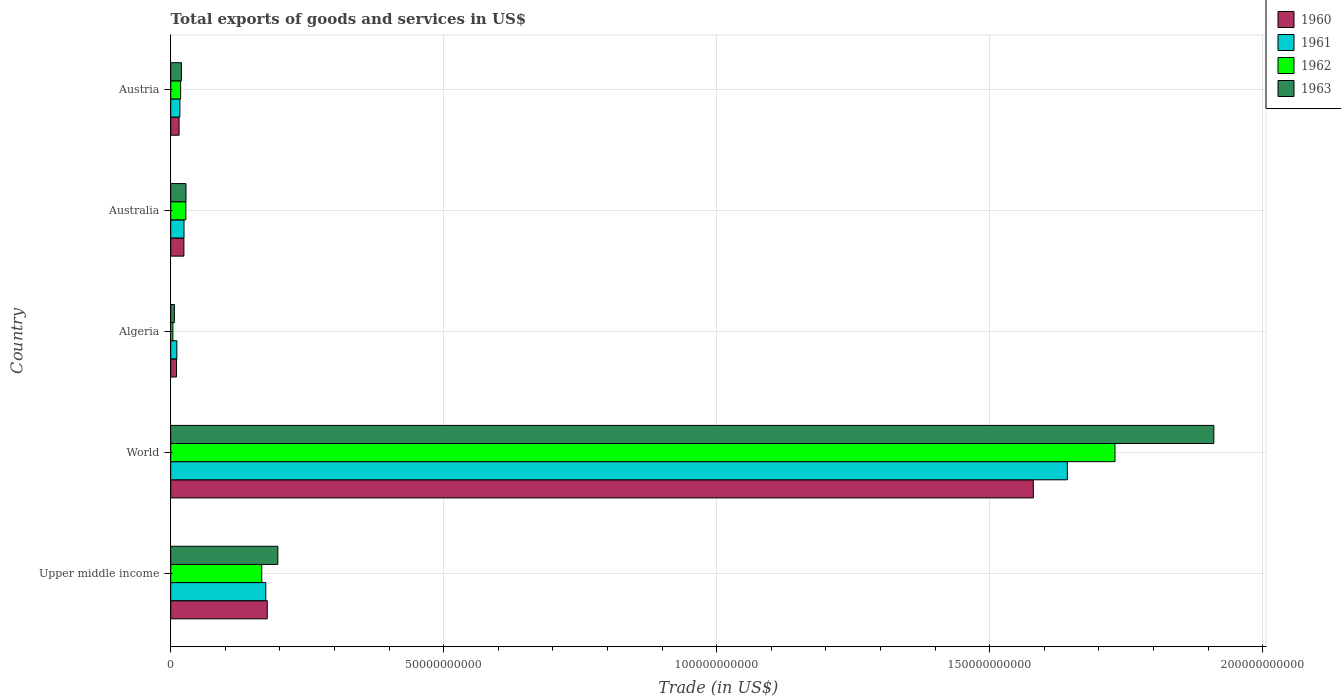Are the number of bars per tick equal to the number of legend labels?
Provide a succinct answer. Yes. Are the number of bars on each tick of the Y-axis equal?
Make the answer very short. Yes. How many bars are there on the 4th tick from the bottom?
Your response must be concise. 4. What is the label of the 3rd group of bars from the top?
Give a very brief answer. Algeria. What is the total exports of goods and services in 1963 in Austria?
Your response must be concise. 1.96e+09. Across all countries, what is the maximum total exports of goods and services in 1963?
Make the answer very short. 1.91e+11. Across all countries, what is the minimum total exports of goods and services in 1962?
Your response must be concise. 3.96e+08. In which country was the total exports of goods and services in 1960 minimum?
Ensure brevity in your answer.  Algeria. What is the total total exports of goods and services in 1960 in the graph?
Your answer should be very brief. 1.81e+11. What is the difference between the total exports of goods and services in 1963 in Algeria and that in Austria?
Your answer should be very brief. -1.29e+09. What is the difference between the total exports of goods and services in 1962 in World and the total exports of goods and services in 1961 in Algeria?
Provide a short and direct response. 1.72e+11. What is the average total exports of goods and services in 1963 per country?
Ensure brevity in your answer.  4.32e+1. What is the difference between the total exports of goods and services in 1963 and total exports of goods and services in 1961 in World?
Make the answer very short. 2.68e+1. What is the ratio of the total exports of goods and services in 1962 in Algeria to that in Upper middle income?
Make the answer very short. 0.02. What is the difference between the highest and the second highest total exports of goods and services in 1963?
Make the answer very short. 1.71e+11. What is the difference between the highest and the lowest total exports of goods and services in 1961?
Your response must be concise. 1.63e+11. In how many countries, is the total exports of goods and services in 1960 greater than the average total exports of goods and services in 1960 taken over all countries?
Offer a very short reply. 1. How many bars are there?
Your answer should be very brief. 20. What is the difference between two consecutive major ticks on the X-axis?
Give a very brief answer. 5.00e+1. Does the graph contain grids?
Ensure brevity in your answer.  Yes. How many legend labels are there?
Offer a very short reply. 4. What is the title of the graph?
Give a very brief answer. Total exports of goods and services in US$. What is the label or title of the X-axis?
Your response must be concise. Trade (in US$). What is the label or title of the Y-axis?
Your response must be concise. Country. What is the Trade (in US$) of 1960 in Upper middle income?
Offer a very short reply. 1.77e+1. What is the Trade (in US$) of 1961 in Upper middle income?
Ensure brevity in your answer.  1.74e+1. What is the Trade (in US$) in 1962 in Upper middle income?
Provide a succinct answer. 1.67e+1. What is the Trade (in US$) in 1963 in Upper middle income?
Make the answer very short. 1.96e+1. What is the Trade (in US$) of 1960 in World?
Keep it short and to the point. 1.58e+11. What is the Trade (in US$) in 1961 in World?
Your answer should be very brief. 1.64e+11. What is the Trade (in US$) of 1962 in World?
Provide a succinct answer. 1.73e+11. What is the Trade (in US$) in 1963 in World?
Offer a very short reply. 1.91e+11. What is the Trade (in US$) of 1960 in Algeria?
Provide a short and direct response. 1.06e+09. What is the Trade (in US$) of 1961 in Algeria?
Your answer should be compact. 1.13e+09. What is the Trade (in US$) of 1962 in Algeria?
Make the answer very short. 3.96e+08. What is the Trade (in US$) of 1963 in Algeria?
Make the answer very short. 6.67e+08. What is the Trade (in US$) in 1960 in Australia?
Provide a succinct answer. 2.41e+09. What is the Trade (in US$) of 1961 in Australia?
Offer a terse response. 2.44e+09. What is the Trade (in US$) of 1962 in Australia?
Keep it short and to the point. 2.77e+09. What is the Trade (in US$) in 1963 in Australia?
Give a very brief answer. 2.80e+09. What is the Trade (in US$) in 1960 in Austria?
Provide a short and direct response. 1.53e+09. What is the Trade (in US$) of 1961 in Austria?
Offer a very short reply. 1.68e+09. What is the Trade (in US$) in 1962 in Austria?
Give a very brief answer. 1.82e+09. What is the Trade (in US$) of 1963 in Austria?
Provide a succinct answer. 1.96e+09. Across all countries, what is the maximum Trade (in US$) of 1960?
Keep it short and to the point. 1.58e+11. Across all countries, what is the maximum Trade (in US$) in 1961?
Ensure brevity in your answer.  1.64e+11. Across all countries, what is the maximum Trade (in US$) in 1962?
Make the answer very short. 1.73e+11. Across all countries, what is the maximum Trade (in US$) in 1963?
Ensure brevity in your answer.  1.91e+11. Across all countries, what is the minimum Trade (in US$) in 1960?
Keep it short and to the point. 1.06e+09. Across all countries, what is the minimum Trade (in US$) in 1961?
Make the answer very short. 1.13e+09. Across all countries, what is the minimum Trade (in US$) of 1962?
Keep it short and to the point. 3.96e+08. Across all countries, what is the minimum Trade (in US$) in 1963?
Give a very brief answer. 6.67e+08. What is the total Trade (in US$) in 1960 in the graph?
Provide a succinct answer. 1.81e+11. What is the total Trade (in US$) in 1961 in the graph?
Give a very brief answer. 1.87e+11. What is the total Trade (in US$) of 1962 in the graph?
Provide a short and direct response. 1.95e+11. What is the total Trade (in US$) in 1963 in the graph?
Keep it short and to the point. 2.16e+11. What is the difference between the Trade (in US$) in 1960 in Upper middle income and that in World?
Give a very brief answer. -1.40e+11. What is the difference between the Trade (in US$) in 1961 in Upper middle income and that in World?
Provide a succinct answer. -1.47e+11. What is the difference between the Trade (in US$) of 1962 in Upper middle income and that in World?
Offer a very short reply. -1.56e+11. What is the difference between the Trade (in US$) of 1963 in Upper middle income and that in World?
Ensure brevity in your answer.  -1.71e+11. What is the difference between the Trade (in US$) in 1960 in Upper middle income and that in Algeria?
Give a very brief answer. 1.66e+1. What is the difference between the Trade (in US$) of 1961 in Upper middle income and that in Algeria?
Provide a succinct answer. 1.63e+1. What is the difference between the Trade (in US$) of 1962 in Upper middle income and that in Algeria?
Provide a short and direct response. 1.63e+1. What is the difference between the Trade (in US$) of 1963 in Upper middle income and that in Algeria?
Provide a succinct answer. 1.90e+1. What is the difference between the Trade (in US$) of 1960 in Upper middle income and that in Australia?
Offer a very short reply. 1.53e+1. What is the difference between the Trade (in US$) in 1961 in Upper middle income and that in Australia?
Offer a very short reply. 1.50e+1. What is the difference between the Trade (in US$) of 1962 in Upper middle income and that in Australia?
Make the answer very short. 1.39e+1. What is the difference between the Trade (in US$) in 1963 in Upper middle income and that in Australia?
Keep it short and to the point. 1.68e+1. What is the difference between the Trade (in US$) in 1960 in Upper middle income and that in Austria?
Ensure brevity in your answer.  1.62e+1. What is the difference between the Trade (in US$) of 1961 in Upper middle income and that in Austria?
Provide a short and direct response. 1.57e+1. What is the difference between the Trade (in US$) of 1962 in Upper middle income and that in Austria?
Provide a succinct answer. 1.49e+1. What is the difference between the Trade (in US$) in 1963 in Upper middle income and that in Austria?
Make the answer very short. 1.77e+1. What is the difference between the Trade (in US$) in 1960 in World and that in Algeria?
Provide a short and direct response. 1.57e+11. What is the difference between the Trade (in US$) of 1961 in World and that in Algeria?
Provide a succinct answer. 1.63e+11. What is the difference between the Trade (in US$) in 1962 in World and that in Algeria?
Give a very brief answer. 1.73e+11. What is the difference between the Trade (in US$) in 1963 in World and that in Algeria?
Your answer should be compact. 1.90e+11. What is the difference between the Trade (in US$) of 1960 in World and that in Australia?
Provide a short and direct response. 1.56e+11. What is the difference between the Trade (in US$) in 1961 in World and that in Australia?
Provide a succinct answer. 1.62e+11. What is the difference between the Trade (in US$) in 1962 in World and that in Australia?
Your answer should be compact. 1.70e+11. What is the difference between the Trade (in US$) in 1963 in World and that in Australia?
Offer a very short reply. 1.88e+11. What is the difference between the Trade (in US$) in 1960 in World and that in Austria?
Offer a very short reply. 1.56e+11. What is the difference between the Trade (in US$) of 1961 in World and that in Austria?
Ensure brevity in your answer.  1.63e+11. What is the difference between the Trade (in US$) in 1962 in World and that in Austria?
Ensure brevity in your answer.  1.71e+11. What is the difference between the Trade (in US$) of 1963 in World and that in Austria?
Your answer should be very brief. 1.89e+11. What is the difference between the Trade (in US$) in 1960 in Algeria and that in Australia?
Make the answer very short. -1.35e+09. What is the difference between the Trade (in US$) of 1961 in Algeria and that in Australia?
Give a very brief answer. -1.31e+09. What is the difference between the Trade (in US$) of 1962 in Algeria and that in Australia?
Offer a terse response. -2.38e+09. What is the difference between the Trade (in US$) in 1963 in Algeria and that in Australia?
Keep it short and to the point. -2.13e+09. What is the difference between the Trade (in US$) of 1960 in Algeria and that in Austria?
Ensure brevity in your answer.  -4.69e+08. What is the difference between the Trade (in US$) of 1961 in Algeria and that in Austria?
Offer a terse response. -5.56e+08. What is the difference between the Trade (in US$) of 1962 in Algeria and that in Austria?
Make the answer very short. -1.42e+09. What is the difference between the Trade (in US$) of 1963 in Algeria and that in Austria?
Give a very brief answer. -1.29e+09. What is the difference between the Trade (in US$) in 1960 in Australia and that in Austria?
Provide a short and direct response. 8.81e+08. What is the difference between the Trade (in US$) in 1961 in Australia and that in Austria?
Your answer should be compact. 7.55e+08. What is the difference between the Trade (in US$) of 1962 in Australia and that in Austria?
Your answer should be compact. 9.57e+08. What is the difference between the Trade (in US$) in 1963 in Australia and that in Austria?
Give a very brief answer. 8.35e+08. What is the difference between the Trade (in US$) of 1960 in Upper middle income and the Trade (in US$) of 1961 in World?
Give a very brief answer. -1.47e+11. What is the difference between the Trade (in US$) in 1960 in Upper middle income and the Trade (in US$) in 1962 in World?
Keep it short and to the point. -1.55e+11. What is the difference between the Trade (in US$) in 1960 in Upper middle income and the Trade (in US$) in 1963 in World?
Offer a terse response. -1.73e+11. What is the difference between the Trade (in US$) of 1961 in Upper middle income and the Trade (in US$) of 1962 in World?
Make the answer very short. -1.56e+11. What is the difference between the Trade (in US$) in 1961 in Upper middle income and the Trade (in US$) in 1963 in World?
Your answer should be compact. -1.74e+11. What is the difference between the Trade (in US$) in 1962 in Upper middle income and the Trade (in US$) in 1963 in World?
Your answer should be very brief. -1.74e+11. What is the difference between the Trade (in US$) in 1960 in Upper middle income and the Trade (in US$) in 1961 in Algeria?
Your answer should be compact. 1.66e+1. What is the difference between the Trade (in US$) of 1960 in Upper middle income and the Trade (in US$) of 1962 in Algeria?
Ensure brevity in your answer.  1.73e+1. What is the difference between the Trade (in US$) of 1960 in Upper middle income and the Trade (in US$) of 1963 in Algeria?
Give a very brief answer. 1.70e+1. What is the difference between the Trade (in US$) in 1961 in Upper middle income and the Trade (in US$) in 1962 in Algeria?
Offer a terse response. 1.70e+1. What is the difference between the Trade (in US$) of 1961 in Upper middle income and the Trade (in US$) of 1963 in Algeria?
Provide a short and direct response. 1.67e+1. What is the difference between the Trade (in US$) of 1962 in Upper middle income and the Trade (in US$) of 1963 in Algeria?
Offer a very short reply. 1.60e+1. What is the difference between the Trade (in US$) of 1960 in Upper middle income and the Trade (in US$) of 1961 in Australia?
Keep it short and to the point. 1.52e+1. What is the difference between the Trade (in US$) of 1960 in Upper middle income and the Trade (in US$) of 1962 in Australia?
Offer a terse response. 1.49e+1. What is the difference between the Trade (in US$) of 1960 in Upper middle income and the Trade (in US$) of 1963 in Australia?
Offer a terse response. 1.49e+1. What is the difference between the Trade (in US$) of 1961 in Upper middle income and the Trade (in US$) of 1962 in Australia?
Make the answer very short. 1.46e+1. What is the difference between the Trade (in US$) in 1961 in Upper middle income and the Trade (in US$) in 1963 in Australia?
Make the answer very short. 1.46e+1. What is the difference between the Trade (in US$) of 1962 in Upper middle income and the Trade (in US$) of 1963 in Australia?
Your answer should be compact. 1.39e+1. What is the difference between the Trade (in US$) of 1960 in Upper middle income and the Trade (in US$) of 1961 in Austria?
Ensure brevity in your answer.  1.60e+1. What is the difference between the Trade (in US$) of 1960 in Upper middle income and the Trade (in US$) of 1962 in Austria?
Give a very brief answer. 1.59e+1. What is the difference between the Trade (in US$) in 1960 in Upper middle income and the Trade (in US$) in 1963 in Austria?
Your answer should be compact. 1.57e+1. What is the difference between the Trade (in US$) of 1961 in Upper middle income and the Trade (in US$) of 1962 in Austria?
Offer a very short reply. 1.56e+1. What is the difference between the Trade (in US$) in 1961 in Upper middle income and the Trade (in US$) in 1963 in Austria?
Provide a short and direct response. 1.55e+1. What is the difference between the Trade (in US$) of 1962 in Upper middle income and the Trade (in US$) of 1963 in Austria?
Keep it short and to the point. 1.47e+1. What is the difference between the Trade (in US$) of 1960 in World and the Trade (in US$) of 1961 in Algeria?
Keep it short and to the point. 1.57e+11. What is the difference between the Trade (in US$) of 1960 in World and the Trade (in US$) of 1962 in Algeria?
Ensure brevity in your answer.  1.58e+11. What is the difference between the Trade (in US$) in 1960 in World and the Trade (in US$) in 1963 in Algeria?
Offer a terse response. 1.57e+11. What is the difference between the Trade (in US$) of 1961 in World and the Trade (in US$) of 1962 in Algeria?
Your answer should be compact. 1.64e+11. What is the difference between the Trade (in US$) in 1961 in World and the Trade (in US$) in 1963 in Algeria?
Offer a very short reply. 1.64e+11. What is the difference between the Trade (in US$) of 1962 in World and the Trade (in US$) of 1963 in Algeria?
Give a very brief answer. 1.72e+11. What is the difference between the Trade (in US$) in 1960 in World and the Trade (in US$) in 1961 in Australia?
Ensure brevity in your answer.  1.56e+11. What is the difference between the Trade (in US$) in 1960 in World and the Trade (in US$) in 1962 in Australia?
Your response must be concise. 1.55e+11. What is the difference between the Trade (in US$) of 1960 in World and the Trade (in US$) of 1963 in Australia?
Your answer should be compact. 1.55e+11. What is the difference between the Trade (in US$) in 1961 in World and the Trade (in US$) in 1962 in Australia?
Make the answer very short. 1.61e+11. What is the difference between the Trade (in US$) of 1961 in World and the Trade (in US$) of 1963 in Australia?
Make the answer very short. 1.61e+11. What is the difference between the Trade (in US$) of 1962 in World and the Trade (in US$) of 1963 in Australia?
Give a very brief answer. 1.70e+11. What is the difference between the Trade (in US$) in 1960 in World and the Trade (in US$) in 1961 in Austria?
Offer a very short reply. 1.56e+11. What is the difference between the Trade (in US$) in 1960 in World and the Trade (in US$) in 1962 in Austria?
Ensure brevity in your answer.  1.56e+11. What is the difference between the Trade (in US$) in 1960 in World and the Trade (in US$) in 1963 in Austria?
Your answer should be compact. 1.56e+11. What is the difference between the Trade (in US$) in 1961 in World and the Trade (in US$) in 1962 in Austria?
Keep it short and to the point. 1.62e+11. What is the difference between the Trade (in US$) in 1961 in World and the Trade (in US$) in 1963 in Austria?
Provide a short and direct response. 1.62e+11. What is the difference between the Trade (in US$) of 1962 in World and the Trade (in US$) of 1963 in Austria?
Your answer should be very brief. 1.71e+11. What is the difference between the Trade (in US$) in 1960 in Algeria and the Trade (in US$) in 1961 in Australia?
Ensure brevity in your answer.  -1.37e+09. What is the difference between the Trade (in US$) in 1960 in Algeria and the Trade (in US$) in 1962 in Australia?
Keep it short and to the point. -1.71e+09. What is the difference between the Trade (in US$) of 1960 in Algeria and the Trade (in US$) of 1963 in Australia?
Provide a succinct answer. -1.73e+09. What is the difference between the Trade (in US$) of 1961 in Algeria and the Trade (in US$) of 1962 in Australia?
Provide a succinct answer. -1.65e+09. What is the difference between the Trade (in US$) of 1961 in Algeria and the Trade (in US$) of 1963 in Australia?
Provide a succinct answer. -1.67e+09. What is the difference between the Trade (in US$) of 1962 in Algeria and the Trade (in US$) of 1963 in Australia?
Provide a succinct answer. -2.40e+09. What is the difference between the Trade (in US$) of 1960 in Algeria and the Trade (in US$) of 1961 in Austria?
Your answer should be compact. -6.19e+08. What is the difference between the Trade (in US$) in 1960 in Algeria and the Trade (in US$) in 1962 in Austria?
Provide a succinct answer. -7.53e+08. What is the difference between the Trade (in US$) of 1960 in Algeria and the Trade (in US$) of 1963 in Austria?
Make the answer very short. -8.98e+08. What is the difference between the Trade (in US$) of 1961 in Algeria and the Trade (in US$) of 1962 in Austria?
Provide a succinct answer. -6.90e+08. What is the difference between the Trade (in US$) of 1961 in Algeria and the Trade (in US$) of 1963 in Austria?
Keep it short and to the point. -8.36e+08. What is the difference between the Trade (in US$) in 1962 in Algeria and the Trade (in US$) in 1963 in Austria?
Your answer should be compact. -1.57e+09. What is the difference between the Trade (in US$) in 1960 in Australia and the Trade (in US$) in 1961 in Austria?
Make the answer very short. 7.31e+08. What is the difference between the Trade (in US$) in 1960 in Australia and the Trade (in US$) in 1962 in Austria?
Provide a succinct answer. 5.97e+08. What is the difference between the Trade (in US$) in 1960 in Australia and the Trade (in US$) in 1963 in Austria?
Ensure brevity in your answer.  4.52e+08. What is the difference between the Trade (in US$) of 1961 in Australia and the Trade (in US$) of 1962 in Austria?
Offer a terse response. 6.21e+08. What is the difference between the Trade (in US$) of 1961 in Australia and the Trade (in US$) of 1963 in Austria?
Offer a very short reply. 4.75e+08. What is the difference between the Trade (in US$) in 1962 in Australia and the Trade (in US$) in 1963 in Austria?
Your response must be concise. 8.11e+08. What is the average Trade (in US$) in 1960 per country?
Ensure brevity in your answer.  3.61e+1. What is the average Trade (in US$) of 1961 per country?
Make the answer very short. 3.74e+1. What is the average Trade (in US$) of 1962 per country?
Your answer should be very brief. 3.89e+1. What is the average Trade (in US$) in 1963 per country?
Your response must be concise. 4.32e+1. What is the difference between the Trade (in US$) in 1960 and Trade (in US$) in 1961 in Upper middle income?
Ensure brevity in your answer.  2.71e+08. What is the difference between the Trade (in US$) of 1960 and Trade (in US$) of 1962 in Upper middle income?
Offer a terse response. 1.01e+09. What is the difference between the Trade (in US$) in 1960 and Trade (in US$) in 1963 in Upper middle income?
Make the answer very short. -1.93e+09. What is the difference between the Trade (in US$) of 1961 and Trade (in US$) of 1962 in Upper middle income?
Offer a terse response. 7.39e+08. What is the difference between the Trade (in US$) in 1961 and Trade (in US$) in 1963 in Upper middle income?
Provide a short and direct response. -2.21e+09. What is the difference between the Trade (in US$) of 1962 and Trade (in US$) of 1963 in Upper middle income?
Provide a succinct answer. -2.95e+09. What is the difference between the Trade (in US$) in 1960 and Trade (in US$) in 1961 in World?
Your answer should be compact. -6.23e+09. What is the difference between the Trade (in US$) of 1960 and Trade (in US$) of 1962 in World?
Provide a succinct answer. -1.50e+1. What is the difference between the Trade (in US$) in 1960 and Trade (in US$) in 1963 in World?
Give a very brief answer. -3.31e+1. What is the difference between the Trade (in US$) in 1961 and Trade (in US$) in 1962 in World?
Offer a terse response. -8.73e+09. What is the difference between the Trade (in US$) of 1961 and Trade (in US$) of 1963 in World?
Your answer should be very brief. -2.68e+1. What is the difference between the Trade (in US$) of 1962 and Trade (in US$) of 1963 in World?
Keep it short and to the point. -1.81e+1. What is the difference between the Trade (in US$) of 1960 and Trade (in US$) of 1961 in Algeria?
Give a very brief answer. -6.26e+07. What is the difference between the Trade (in US$) in 1960 and Trade (in US$) in 1962 in Algeria?
Your response must be concise. 6.67e+08. What is the difference between the Trade (in US$) in 1960 and Trade (in US$) in 1963 in Algeria?
Offer a terse response. 3.96e+08. What is the difference between the Trade (in US$) in 1961 and Trade (in US$) in 1962 in Algeria?
Keep it short and to the point. 7.30e+08. What is the difference between the Trade (in US$) in 1961 and Trade (in US$) in 1963 in Algeria?
Provide a short and direct response. 4.59e+08. What is the difference between the Trade (in US$) in 1962 and Trade (in US$) in 1963 in Algeria?
Offer a very short reply. -2.71e+08. What is the difference between the Trade (in US$) of 1960 and Trade (in US$) of 1961 in Australia?
Ensure brevity in your answer.  -2.35e+07. What is the difference between the Trade (in US$) in 1960 and Trade (in US$) in 1962 in Australia?
Your answer should be very brief. -3.60e+08. What is the difference between the Trade (in US$) in 1960 and Trade (in US$) in 1963 in Australia?
Make the answer very short. -3.83e+08. What is the difference between the Trade (in US$) of 1961 and Trade (in US$) of 1962 in Australia?
Your answer should be compact. -3.36e+08. What is the difference between the Trade (in US$) of 1961 and Trade (in US$) of 1963 in Australia?
Keep it short and to the point. -3.60e+08. What is the difference between the Trade (in US$) in 1962 and Trade (in US$) in 1963 in Australia?
Your answer should be compact. -2.35e+07. What is the difference between the Trade (in US$) in 1960 and Trade (in US$) in 1961 in Austria?
Offer a terse response. -1.49e+08. What is the difference between the Trade (in US$) in 1960 and Trade (in US$) in 1962 in Austria?
Provide a short and direct response. -2.84e+08. What is the difference between the Trade (in US$) in 1960 and Trade (in US$) in 1963 in Austria?
Keep it short and to the point. -4.29e+08. What is the difference between the Trade (in US$) of 1961 and Trade (in US$) of 1962 in Austria?
Offer a terse response. -1.34e+08. What is the difference between the Trade (in US$) of 1961 and Trade (in US$) of 1963 in Austria?
Make the answer very short. -2.80e+08. What is the difference between the Trade (in US$) in 1962 and Trade (in US$) in 1963 in Austria?
Offer a terse response. -1.46e+08. What is the ratio of the Trade (in US$) of 1960 in Upper middle income to that in World?
Your answer should be very brief. 0.11. What is the ratio of the Trade (in US$) of 1961 in Upper middle income to that in World?
Provide a succinct answer. 0.11. What is the ratio of the Trade (in US$) in 1962 in Upper middle income to that in World?
Your answer should be compact. 0.1. What is the ratio of the Trade (in US$) of 1963 in Upper middle income to that in World?
Keep it short and to the point. 0.1. What is the ratio of the Trade (in US$) of 1960 in Upper middle income to that in Algeria?
Offer a very short reply. 16.63. What is the ratio of the Trade (in US$) in 1961 in Upper middle income to that in Algeria?
Provide a succinct answer. 15.47. What is the ratio of the Trade (in US$) in 1962 in Upper middle income to that in Algeria?
Your answer should be very brief. 42.09. What is the ratio of the Trade (in US$) in 1963 in Upper middle income to that in Algeria?
Your response must be concise. 29.41. What is the ratio of the Trade (in US$) of 1960 in Upper middle income to that in Australia?
Your answer should be compact. 7.33. What is the ratio of the Trade (in US$) in 1961 in Upper middle income to that in Australia?
Offer a very short reply. 7.15. What is the ratio of the Trade (in US$) of 1962 in Upper middle income to that in Australia?
Keep it short and to the point. 6.01. What is the ratio of the Trade (in US$) in 1963 in Upper middle income to that in Australia?
Provide a short and direct response. 7.02. What is the ratio of the Trade (in US$) in 1960 in Upper middle income to that in Austria?
Ensure brevity in your answer.  11.54. What is the ratio of the Trade (in US$) in 1961 in Upper middle income to that in Austria?
Ensure brevity in your answer.  10.35. What is the ratio of the Trade (in US$) in 1962 in Upper middle income to that in Austria?
Your answer should be compact. 9.18. What is the ratio of the Trade (in US$) of 1963 in Upper middle income to that in Austria?
Offer a terse response. 10. What is the ratio of the Trade (in US$) of 1960 in World to that in Algeria?
Make the answer very short. 148.58. What is the ratio of the Trade (in US$) of 1961 in World to that in Algeria?
Your answer should be very brief. 145.87. What is the ratio of the Trade (in US$) of 1962 in World to that in Algeria?
Give a very brief answer. 436.59. What is the ratio of the Trade (in US$) of 1963 in World to that in Algeria?
Make the answer very short. 286.36. What is the ratio of the Trade (in US$) of 1960 in World to that in Australia?
Ensure brevity in your answer.  65.47. What is the ratio of the Trade (in US$) in 1961 in World to that in Australia?
Your response must be concise. 67.39. What is the ratio of the Trade (in US$) in 1962 in World to that in Australia?
Your answer should be very brief. 62.37. What is the ratio of the Trade (in US$) in 1963 in World to that in Australia?
Offer a terse response. 68.32. What is the ratio of the Trade (in US$) of 1960 in World to that in Austria?
Your answer should be very brief. 103.09. What is the ratio of the Trade (in US$) of 1961 in World to that in Austria?
Make the answer very short. 97.64. What is the ratio of the Trade (in US$) in 1962 in World to that in Austria?
Provide a short and direct response. 95.23. What is the ratio of the Trade (in US$) in 1963 in World to that in Austria?
Provide a short and direct response. 97.39. What is the ratio of the Trade (in US$) in 1960 in Algeria to that in Australia?
Keep it short and to the point. 0.44. What is the ratio of the Trade (in US$) in 1961 in Algeria to that in Australia?
Keep it short and to the point. 0.46. What is the ratio of the Trade (in US$) in 1962 in Algeria to that in Australia?
Provide a short and direct response. 0.14. What is the ratio of the Trade (in US$) of 1963 in Algeria to that in Australia?
Give a very brief answer. 0.24. What is the ratio of the Trade (in US$) in 1960 in Algeria to that in Austria?
Provide a succinct answer. 0.69. What is the ratio of the Trade (in US$) of 1961 in Algeria to that in Austria?
Keep it short and to the point. 0.67. What is the ratio of the Trade (in US$) of 1962 in Algeria to that in Austria?
Give a very brief answer. 0.22. What is the ratio of the Trade (in US$) in 1963 in Algeria to that in Austria?
Your answer should be compact. 0.34. What is the ratio of the Trade (in US$) in 1960 in Australia to that in Austria?
Keep it short and to the point. 1.57. What is the ratio of the Trade (in US$) of 1961 in Australia to that in Austria?
Offer a terse response. 1.45. What is the ratio of the Trade (in US$) of 1962 in Australia to that in Austria?
Make the answer very short. 1.53. What is the ratio of the Trade (in US$) in 1963 in Australia to that in Austria?
Offer a terse response. 1.43. What is the difference between the highest and the second highest Trade (in US$) in 1960?
Offer a terse response. 1.40e+11. What is the difference between the highest and the second highest Trade (in US$) of 1961?
Keep it short and to the point. 1.47e+11. What is the difference between the highest and the second highest Trade (in US$) of 1962?
Ensure brevity in your answer.  1.56e+11. What is the difference between the highest and the second highest Trade (in US$) of 1963?
Offer a very short reply. 1.71e+11. What is the difference between the highest and the lowest Trade (in US$) in 1960?
Give a very brief answer. 1.57e+11. What is the difference between the highest and the lowest Trade (in US$) of 1961?
Keep it short and to the point. 1.63e+11. What is the difference between the highest and the lowest Trade (in US$) in 1962?
Keep it short and to the point. 1.73e+11. What is the difference between the highest and the lowest Trade (in US$) of 1963?
Ensure brevity in your answer.  1.90e+11. 